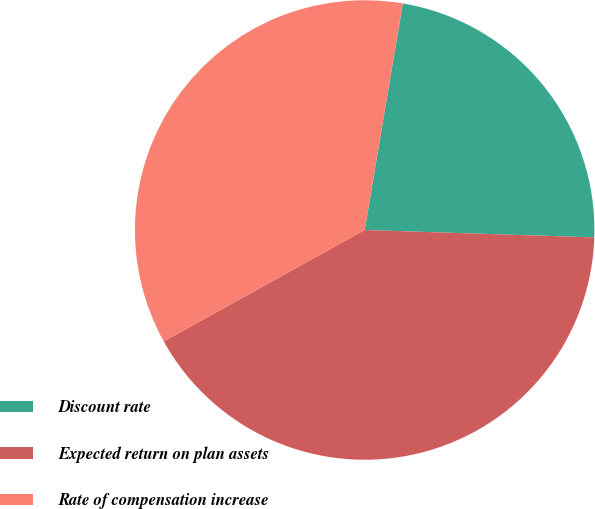<chart> <loc_0><loc_0><loc_500><loc_500><pie_chart><fcel>Discount rate<fcel>Expected return on plan assets<fcel>Rate of compensation increase<nl><fcel>22.86%<fcel>41.43%<fcel>35.71%<nl></chart> 